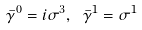<formula> <loc_0><loc_0><loc_500><loc_500>\bar { \gamma } ^ { 0 } = i \sigma ^ { 3 } , \ \bar { \gamma } ^ { 1 } = \sigma ^ { 1 }</formula> 